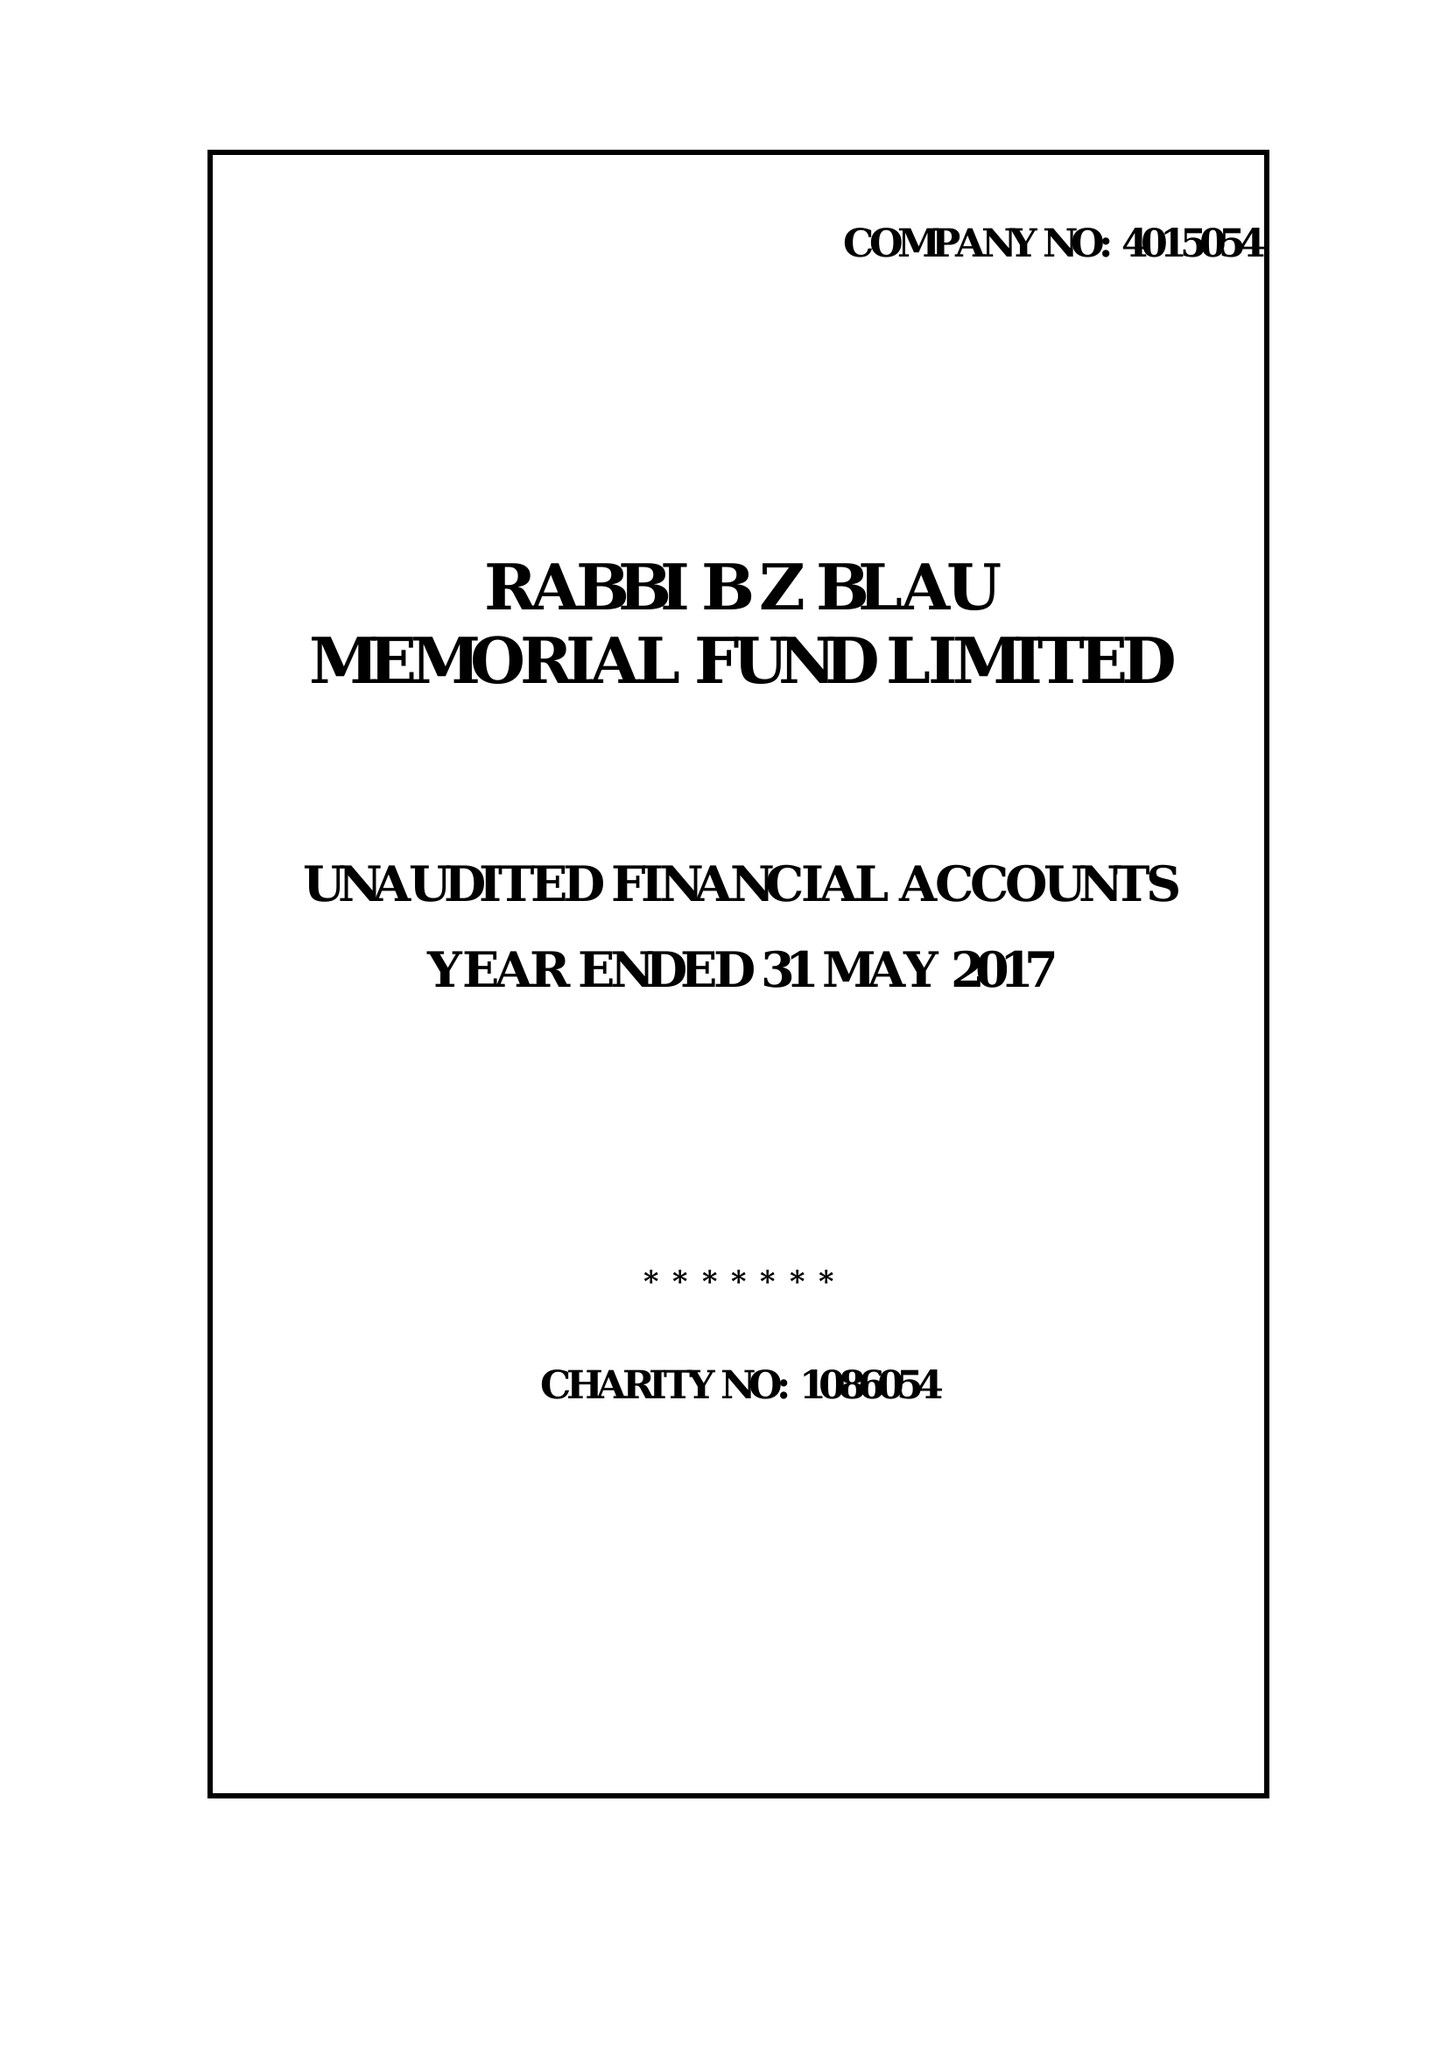What is the value for the spending_annually_in_british_pounds?
Answer the question using a single word or phrase. 33933.00 